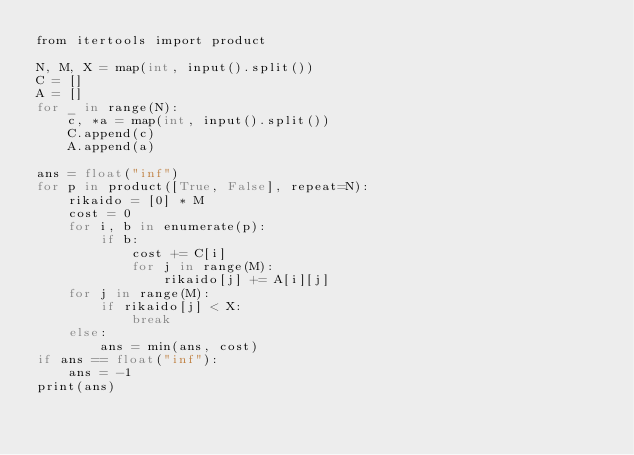Convert code to text. <code><loc_0><loc_0><loc_500><loc_500><_Cython_>from itertools import product

N, M, X = map(int, input().split())
C = []
A = []
for _ in range(N):
    c, *a = map(int, input().split())
    C.append(c)
    A.append(a)

ans = float("inf")
for p in product([True, False], repeat=N):
    rikaido = [0] * M
    cost = 0
    for i, b in enumerate(p):
        if b:
            cost += C[i]
            for j in range(M):
                rikaido[j] += A[i][j]
    for j in range(M):
        if rikaido[j] < X:
            break
    else:
        ans = min(ans, cost)
if ans == float("inf"):
    ans = -1
print(ans)
</code> 